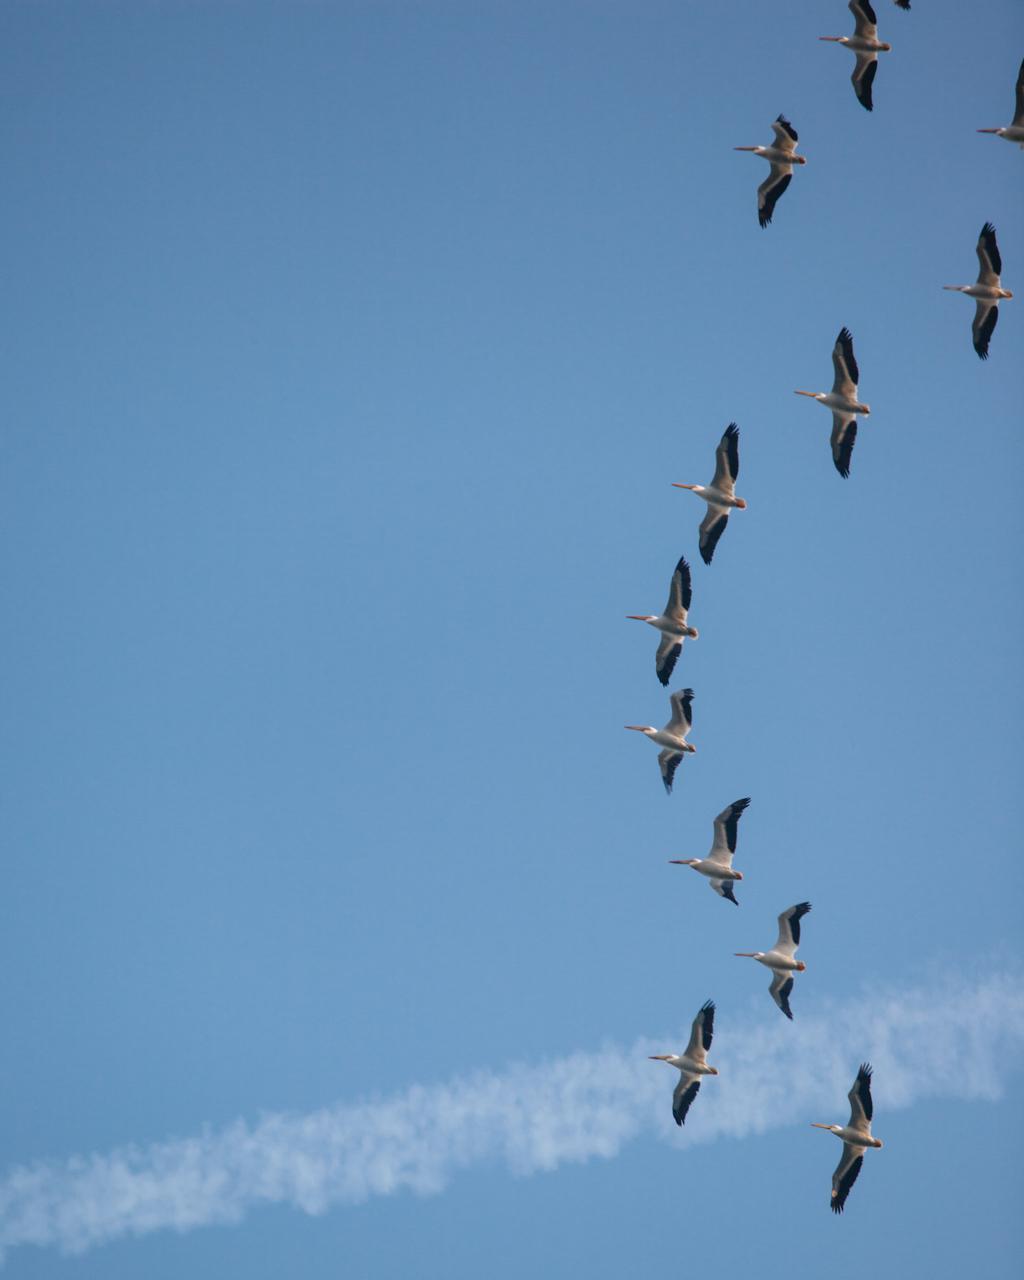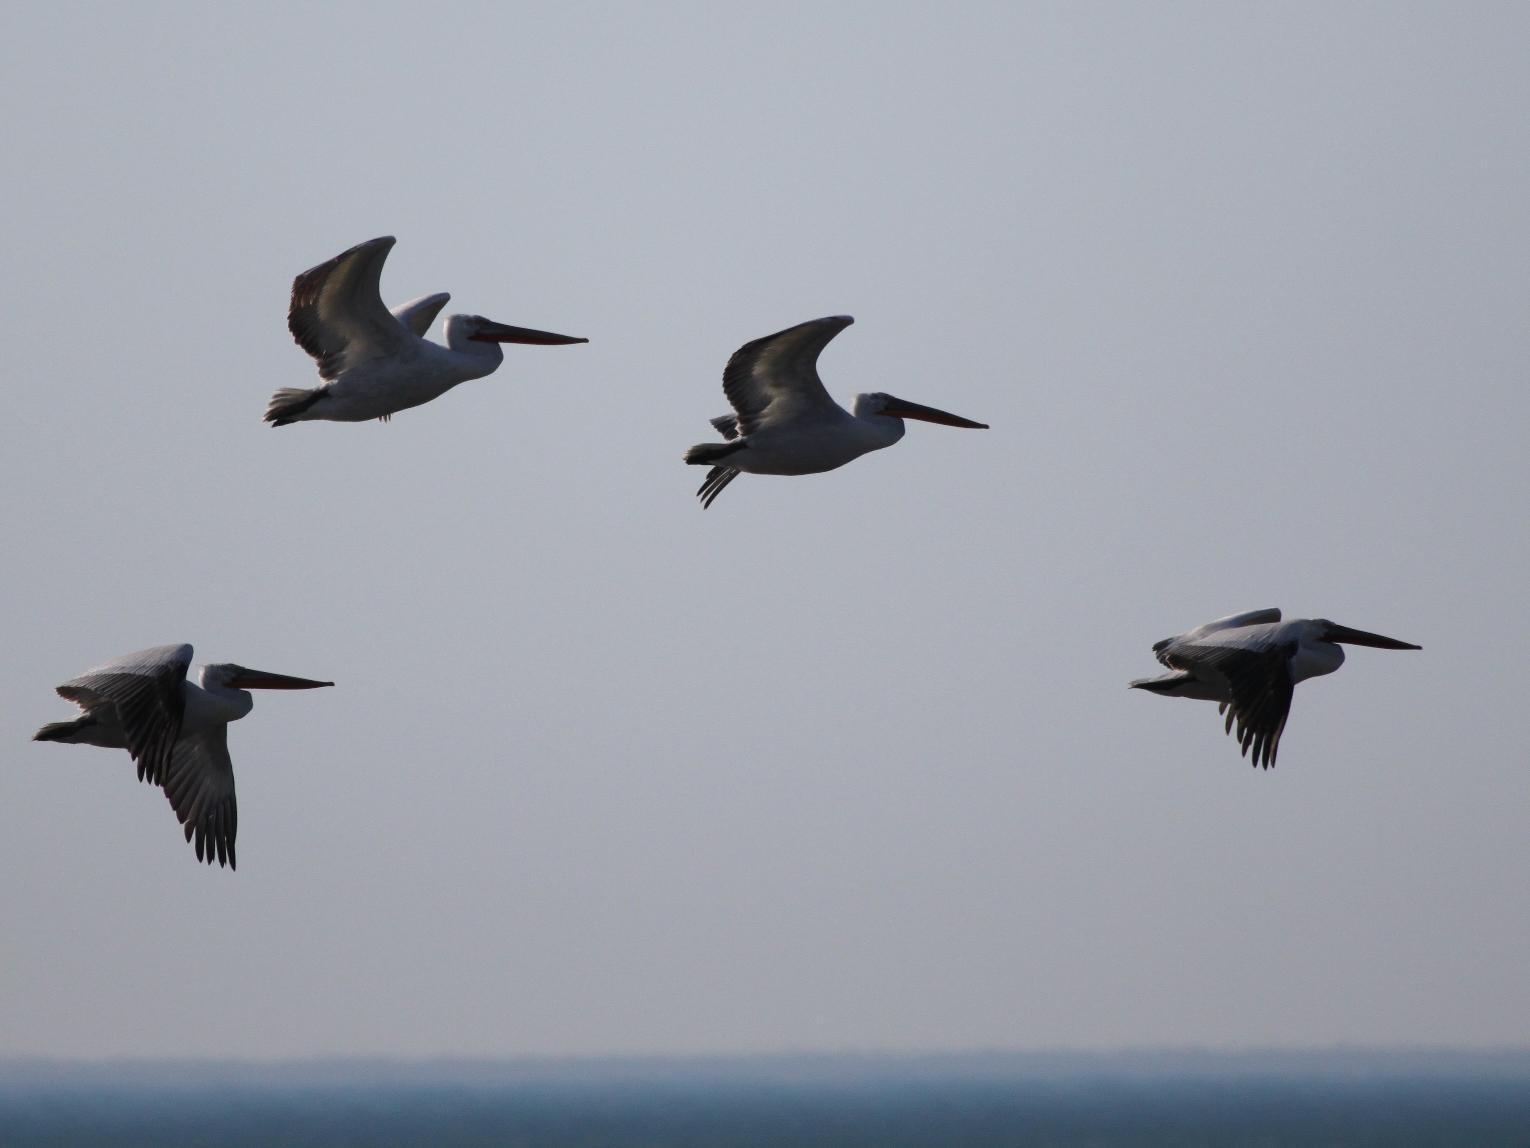The first image is the image on the left, the second image is the image on the right. Examine the images to the left and right. Is the description "Four or fewer birds are flying through the air in one image." accurate? Answer yes or no. Yes. The first image is the image on the left, the second image is the image on the right. Analyze the images presented: Is the assertion "One image contains less than 5 flying birds." valid? Answer yes or no. Yes. 